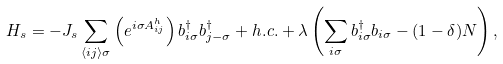<formula> <loc_0><loc_0><loc_500><loc_500>H _ { s } = - J _ { s } \sum _ { \langle i j \rangle \sigma } \left ( e ^ { i \sigma A _ { i j } ^ { h } } \right ) b _ { i \sigma } ^ { \dagger } b _ { j - \sigma } ^ { \dagger } + h . c . + \lambda \left ( \sum _ { i \sigma } b _ { i \sigma } ^ { \dagger } b _ { i \sigma } - ( 1 - \delta ) N \right ) ,</formula> 